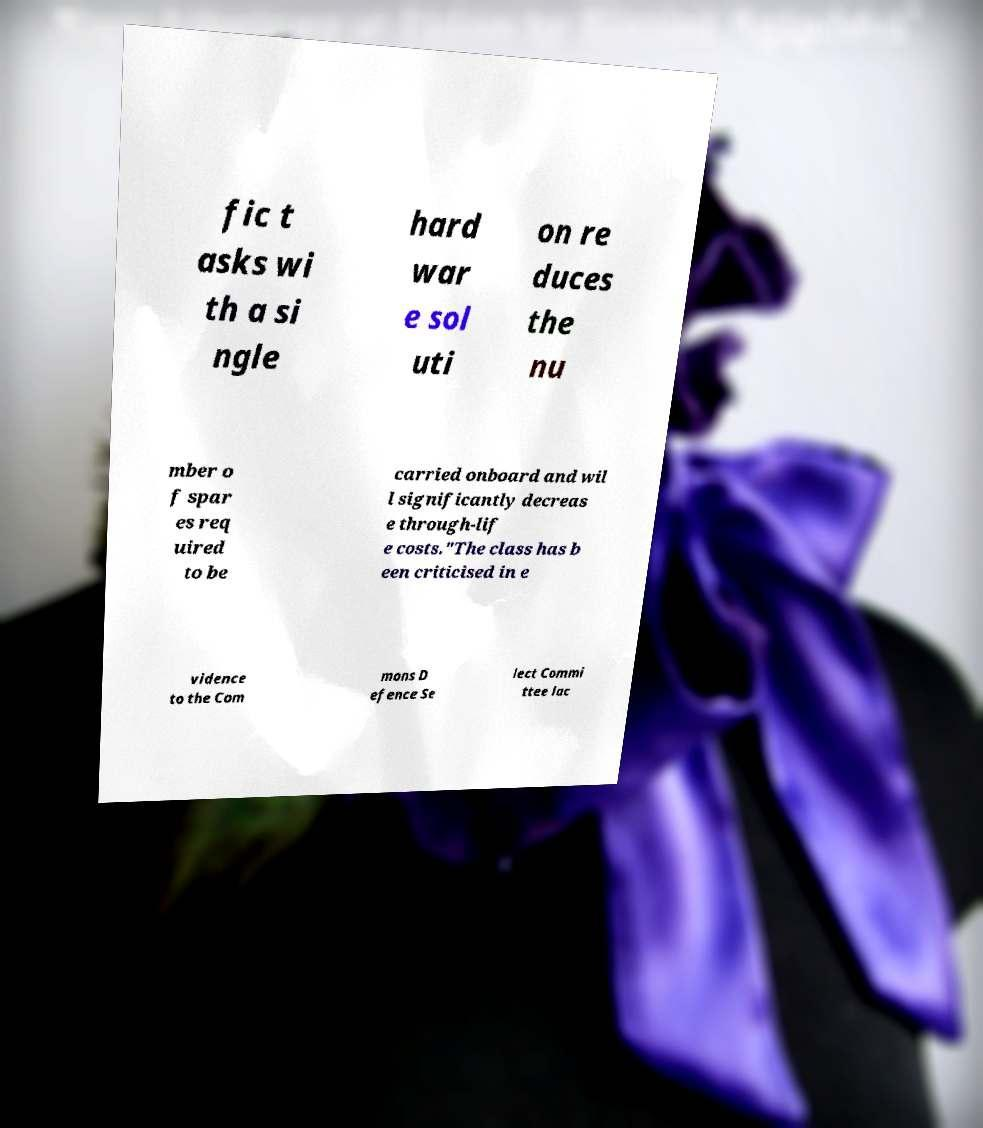Can you accurately transcribe the text from the provided image for me? fic t asks wi th a si ngle hard war e sol uti on re duces the nu mber o f spar es req uired to be carried onboard and wil l significantly decreas e through-lif e costs."The class has b een criticised in e vidence to the Com mons D efence Se lect Commi ttee lac 